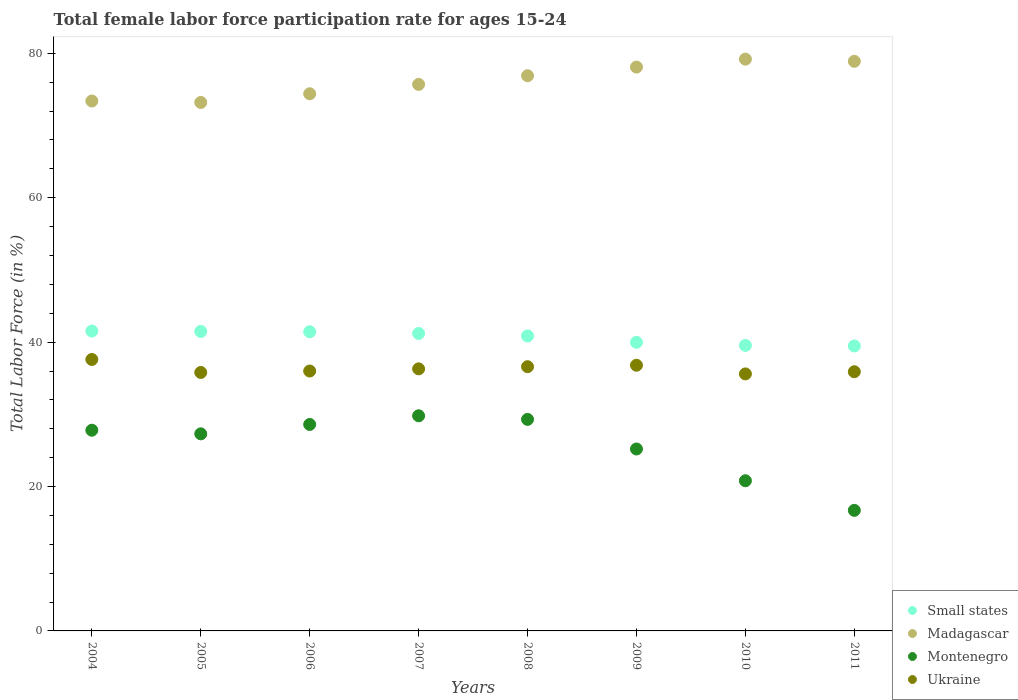How many different coloured dotlines are there?
Your answer should be compact. 4. What is the female labor force participation rate in Madagascar in 2009?
Ensure brevity in your answer.  78.1. Across all years, what is the maximum female labor force participation rate in Madagascar?
Your answer should be very brief. 79.2. Across all years, what is the minimum female labor force participation rate in Madagascar?
Your response must be concise. 73.2. What is the total female labor force participation rate in Small states in the graph?
Ensure brevity in your answer.  325.51. What is the difference between the female labor force participation rate in Madagascar in 2004 and that in 2008?
Ensure brevity in your answer.  -3.5. What is the difference between the female labor force participation rate in Small states in 2005 and the female labor force participation rate in Madagascar in 2007?
Offer a terse response. -34.21. What is the average female labor force participation rate in Ukraine per year?
Offer a terse response. 36.32. In the year 2006, what is the difference between the female labor force participation rate in Montenegro and female labor force participation rate in Ukraine?
Ensure brevity in your answer.  -7.4. In how many years, is the female labor force participation rate in Ukraine greater than 28 %?
Offer a terse response. 8. What is the ratio of the female labor force participation rate in Montenegro in 2008 to that in 2010?
Make the answer very short. 1.41. What is the difference between the highest and the second highest female labor force participation rate in Montenegro?
Your answer should be very brief. 0.5. What is the difference between the highest and the lowest female labor force participation rate in Madagascar?
Offer a very short reply. 6. Is the sum of the female labor force participation rate in Small states in 2004 and 2010 greater than the maximum female labor force participation rate in Madagascar across all years?
Make the answer very short. Yes. Is it the case that in every year, the sum of the female labor force participation rate in Ukraine and female labor force participation rate in Madagascar  is greater than the sum of female labor force participation rate in Small states and female labor force participation rate in Montenegro?
Your answer should be compact. Yes. Is it the case that in every year, the sum of the female labor force participation rate in Small states and female labor force participation rate in Ukraine  is greater than the female labor force participation rate in Montenegro?
Offer a very short reply. Yes. Does the female labor force participation rate in Madagascar monotonically increase over the years?
Your answer should be compact. No. Is the female labor force participation rate in Small states strictly greater than the female labor force participation rate in Madagascar over the years?
Keep it short and to the point. No. How many dotlines are there?
Ensure brevity in your answer.  4. How many years are there in the graph?
Your answer should be compact. 8. Where does the legend appear in the graph?
Ensure brevity in your answer.  Bottom right. What is the title of the graph?
Your response must be concise. Total female labor force participation rate for ages 15-24. What is the Total Labor Force (in %) of Small states in 2004?
Ensure brevity in your answer.  41.54. What is the Total Labor Force (in %) of Madagascar in 2004?
Offer a very short reply. 73.4. What is the Total Labor Force (in %) in Montenegro in 2004?
Make the answer very short. 27.8. What is the Total Labor Force (in %) of Ukraine in 2004?
Your response must be concise. 37.6. What is the Total Labor Force (in %) in Small states in 2005?
Make the answer very short. 41.49. What is the Total Labor Force (in %) in Madagascar in 2005?
Give a very brief answer. 73.2. What is the Total Labor Force (in %) in Montenegro in 2005?
Your response must be concise. 27.3. What is the Total Labor Force (in %) of Ukraine in 2005?
Make the answer very short. 35.8. What is the Total Labor Force (in %) in Small states in 2006?
Your answer should be very brief. 41.44. What is the Total Labor Force (in %) of Madagascar in 2006?
Give a very brief answer. 74.4. What is the Total Labor Force (in %) in Montenegro in 2006?
Keep it short and to the point. 28.6. What is the Total Labor Force (in %) in Ukraine in 2006?
Ensure brevity in your answer.  36. What is the Total Labor Force (in %) in Small states in 2007?
Your answer should be compact. 41.2. What is the Total Labor Force (in %) of Madagascar in 2007?
Give a very brief answer. 75.7. What is the Total Labor Force (in %) of Montenegro in 2007?
Ensure brevity in your answer.  29.8. What is the Total Labor Force (in %) in Ukraine in 2007?
Make the answer very short. 36.3. What is the Total Labor Force (in %) in Small states in 2008?
Provide a short and direct response. 40.86. What is the Total Labor Force (in %) in Madagascar in 2008?
Your answer should be very brief. 76.9. What is the Total Labor Force (in %) of Montenegro in 2008?
Provide a short and direct response. 29.3. What is the Total Labor Force (in %) of Ukraine in 2008?
Offer a very short reply. 36.6. What is the Total Labor Force (in %) of Small states in 2009?
Provide a succinct answer. 39.97. What is the Total Labor Force (in %) of Madagascar in 2009?
Your answer should be compact. 78.1. What is the Total Labor Force (in %) of Montenegro in 2009?
Your answer should be compact. 25.2. What is the Total Labor Force (in %) of Ukraine in 2009?
Provide a short and direct response. 36.8. What is the Total Labor Force (in %) of Small states in 2010?
Offer a very short reply. 39.54. What is the Total Labor Force (in %) in Madagascar in 2010?
Give a very brief answer. 79.2. What is the Total Labor Force (in %) in Montenegro in 2010?
Make the answer very short. 20.8. What is the Total Labor Force (in %) in Ukraine in 2010?
Offer a very short reply. 35.6. What is the Total Labor Force (in %) of Small states in 2011?
Your answer should be very brief. 39.47. What is the Total Labor Force (in %) in Madagascar in 2011?
Provide a short and direct response. 78.9. What is the Total Labor Force (in %) in Montenegro in 2011?
Keep it short and to the point. 16.7. What is the Total Labor Force (in %) of Ukraine in 2011?
Keep it short and to the point. 35.9. Across all years, what is the maximum Total Labor Force (in %) of Small states?
Your response must be concise. 41.54. Across all years, what is the maximum Total Labor Force (in %) in Madagascar?
Give a very brief answer. 79.2. Across all years, what is the maximum Total Labor Force (in %) in Montenegro?
Give a very brief answer. 29.8. Across all years, what is the maximum Total Labor Force (in %) of Ukraine?
Your response must be concise. 37.6. Across all years, what is the minimum Total Labor Force (in %) of Small states?
Give a very brief answer. 39.47. Across all years, what is the minimum Total Labor Force (in %) of Madagascar?
Keep it short and to the point. 73.2. Across all years, what is the minimum Total Labor Force (in %) of Montenegro?
Ensure brevity in your answer.  16.7. Across all years, what is the minimum Total Labor Force (in %) of Ukraine?
Ensure brevity in your answer.  35.6. What is the total Total Labor Force (in %) of Small states in the graph?
Make the answer very short. 325.51. What is the total Total Labor Force (in %) in Madagascar in the graph?
Offer a terse response. 609.8. What is the total Total Labor Force (in %) of Montenegro in the graph?
Keep it short and to the point. 205.5. What is the total Total Labor Force (in %) in Ukraine in the graph?
Offer a terse response. 290.6. What is the difference between the Total Labor Force (in %) of Small states in 2004 and that in 2005?
Your response must be concise. 0.05. What is the difference between the Total Labor Force (in %) of Ukraine in 2004 and that in 2005?
Provide a short and direct response. 1.8. What is the difference between the Total Labor Force (in %) in Small states in 2004 and that in 2006?
Your answer should be very brief. 0.1. What is the difference between the Total Labor Force (in %) in Madagascar in 2004 and that in 2006?
Provide a short and direct response. -1. What is the difference between the Total Labor Force (in %) in Ukraine in 2004 and that in 2006?
Ensure brevity in your answer.  1.6. What is the difference between the Total Labor Force (in %) in Small states in 2004 and that in 2007?
Provide a succinct answer. 0.34. What is the difference between the Total Labor Force (in %) of Montenegro in 2004 and that in 2007?
Offer a very short reply. -2. What is the difference between the Total Labor Force (in %) in Ukraine in 2004 and that in 2007?
Your answer should be very brief. 1.3. What is the difference between the Total Labor Force (in %) of Small states in 2004 and that in 2008?
Provide a succinct answer. 0.68. What is the difference between the Total Labor Force (in %) in Madagascar in 2004 and that in 2008?
Keep it short and to the point. -3.5. What is the difference between the Total Labor Force (in %) of Ukraine in 2004 and that in 2008?
Your answer should be very brief. 1. What is the difference between the Total Labor Force (in %) in Small states in 2004 and that in 2009?
Keep it short and to the point. 1.56. What is the difference between the Total Labor Force (in %) of Montenegro in 2004 and that in 2009?
Keep it short and to the point. 2.6. What is the difference between the Total Labor Force (in %) in Small states in 2004 and that in 2010?
Offer a very short reply. 1.99. What is the difference between the Total Labor Force (in %) of Madagascar in 2004 and that in 2010?
Your response must be concise. -5.8. What is the difference between the Total Labor Force (in %) of Montenegro in 2004 and that in 2010?
Provide a succinct answer. 7. What is the difference between the Total Labor Force (in %) of Ukraine in 2004 and that in 2010?
Make the answer very short. 2. What is the difference between the Total Labor Force (in %) in Small states in 2004 and that in 2011?
Provide a short and direct response. 2.06. What is the difference between the Total Labor Force (in %) in Madagascar in 2004 and that in 2011?
Provide a succinct answer. -5.5. What is the difference between the Total Labor Force (in %) in Ukraine in 2004 and that in 2011?
Make the answer very short. 1.7. What is the difference between the Total Labor Force (in %) in Small states in 2005 and that in 2006?
Your answer should be very brief. 0.05. What is the difference between the Total Labor Force (in %) in Madagascar in 2005 and that in 2006?
Your answer should be compact. -1.2. What is the difference between the Total Labor Force (in %) of Ukraine in 2005 and that in 2006?
Offer a very short reply. -0.2. What is the difference between the Total Labor Force (in %) of Small states in 2005 and that in 2007?
Your response must be concise. 0.29. What is the difference between the Total Labor Force (in %) of Ukraine in 2005 and that in 2007?
Provide a succinct answer. -0.5. What is the difference between the Total Labor Force (in %) of Small states in 2005 and that in 2008?
Your answer should be compact. 0.63. What is the difference between the Total Labor Force (in %) in Madagascar in 2005 and that in 2008?
Your response must be concise. -3.7. What is the difference between the Total Labor Force (in %) of Montenegro in 2005 and that in 2008?
Your answer should be compact. -2. What is the difference between the Total Labor Force (in %) of Ukraine in 2005 and that in 2008?
Your answer should be very brief. -0.8. What is the difference between the Total Labor Force (in %) in Small states in 2005 and that in 2009?
Offer a terse response. 1.51. What is the difference between the Total Labor Force (in %) of Ukraine in 2005 and that in 2009?
Offer a terse response. -1. What is the difference between the Total Labor Force (in %) of Small states in 2005 and that in 2010?
Provide a short and direct response. 1.94. What is the difference between the Total Labor Force (in %) in Madagascar in 2005 and that in 2010?
Offer a terse response. -6. What is the difference between the Total Labor Force (in %) in Small states in 2005 and that in 2011?
Provide a succinct answer. 2.01. What is the difference between the Total Labor Force (in %) in Madagascar in 2005 and that in 2011?
Offer a very short reply. -5.7. What is the difference between the Total Labor Force (in %) of Montenegro in 2005 and that in 2011?
Your answer should be compact. 10.6. What is the difference between the Total Labor Force (in %) in Small states in 2006 and that in 2007?
Your answer should be compact. 0.24. What is the difference between the Total Labor Force (in %) in Ukraine in 2006 and that in 2007?
Make the answer very short. -0.3. What is the difference between the Total Labor Force (in %) in Small states in 2006 and that in 2008?
Make the answer very short. 0.58. What is the difference between the Total Labor Force (in %) of Madagascar in 2006 and that in 2008?
Provide a succinct answer. -2.5. What is the difference between the Total Labor Force (in %) in Montenegro in 2006 and that in 2008?
Provide a succinct answer. -0.7. What is the difference between the Total Labor Force (in %) in Small states in 2006 and that in 2009?
Offer a very short reply. 1.47. What is the difference between the Total Labor Force (in %) of Small states in 2006 and that in 2010?
Keep it short and to the point. 1.9. What is the difference between the Total Labor Force (in %) of Small states in 2006 and that in 2011?
Make the answer very short. 1.97. What is the difference between the Total Labor Force (in %) in Madagascar in 2006 and that in 2011?
Provide a succinct answer. -4.5. What is the difference between the Total Labor Force (in %) in Ukraine in 2006 and that in 2011?
Provide a succinct answer. 0.1. What is the difference between the Total Labor Force (in %) of Small states in 2007 and that in 2008?
Keep it short and to the point. 0.34. What is the difference between the Total Labor Force (in %) of Madagascar in 2007 and that in 2008?
Your answer should be very brief. -1.2. What is the difference between the Total Labor Force (in %) in Small states in 2007 and that in 2009?
Offer a very short reply. 1.23. What is the difference between the Total Labor Force (in %) of Madagascar in 2007 and that in 2009?
Keep it short and to the point. -2.4. What is the difference between the Total Labor Force (in %) of Small states in 2007 and that in 2010?
Keep it short and to the point. 1.66. What is the difference between the Total Labor Force (in %) in Madagascar in 2007 and that in 2010?
Your answer should be very brief. -3.5. What is the difference between the Total Labor Force (in %) of Montenegro in 2007 and that in 2010?
Offer a very short reply. 9. What is the difference between the Total Labor Force (in %) in Small states in 2007 and that in 2011?
Give a very brief answer. 1.73. What is the difference between the Total Labor Force (in %) of Ukraine in 2007 and that in 2011?
Provide a short and direct response. 0.4. What is the difference between the Total Labor Force (in %) of Small states in 2008 and that in 2009?
Offer a very short reply. 0.88. What is the difference between the Total Labor Force (in %) in Madagascar in 2008 and that in 2009?
Offer a terse response. -1.2. What is the difference between the Total Labor Force (in %) in Small states in 2008 and that in 2010?
Your answer should be very brief. 1.31. What is the difference between the Total Labor Force (in %) of Madagascar in 2008 and that in 2010?
Offer a terse response. -2.3. What is the difference between the Total Labor Force (in %) of Small states in 2008 and that in 2011?
Provide a succinct answer. 1.39. What is the difference between the Total Labor Force (in %) of Montenegro in 2008 and that in 2011?
Ensure brevity in your answer.  12.6. What is the difference between the Total Labor Force (in %) of Small states in 2009 and that in 2010?
Offer a very short reply. 0.43. What is the difference between the Total Labor Force (in %) in Montenegro in 2009 and that in 2010?
Keep it short and to the point. 4.4. What is the difference between the Total Labor Force (in %) of Small states in 2009 and that in 2011?
Your answer should be very brief. 0.5. What is the difference between the Total Labor Force (in %) of Montenegro in 2009 and that in 2011?
Keep it short and to the point. 8.5. What is the difference between the Total Labor Force (in %) in Ukraine in 2009 and that in 2011?
Offer a terse response. 0.9. What is the difference between the Total Labor Force (in %) in Small states in 2010 and that in 2011?
Offer a very short reply. 0.07. What is the difference between the Total Labor Force (in %) of Small states in 2004 and the Total Labor Force (in %) of Madagascar in 2005?
Your answer should be compact. -31.66. What is the difference between the Total Labor Force (in %) of Small states in 2004 and the Total Labor Force (in %) of Montenegro in 2005?
Your answer should be compact. 14.24. What is the difference between the Total Labor Force (in %) of Small states in 2004 and the Total Labor Force (in %) of Ukraine in 2005?
Offer a very short reply. 5.74. What is the difference between the Total Labor Force (in %) of Madagascar in 2004 and the Total Labor Force (in %) of Montenegro in 2005?
Your answer should be compact. 46.1. What is the difference between the Total Labor Force (in %) in Madagascar in 2004 and the Total Labor Force (in %) in Ukraine in 2005?
Your answer should be compact. 37.6. What is the difference between the Total Labor Force (in %) in Montenegro in 2004 and the Total Labor Force (in %) in Ukraine in 2005?
Provide a succinct answer. -8. What is the difference between the Total Labor Force (in %) in Small states in 2004 and the Total Labor Force (in %) in Madagascar in 2006?
Ensure brevity in your answer.  -32.86. What is the difference between the Total Labor Force (in %) in Small states in 2004 and the Total Labor Force (in %) in Montenegro in 2006?
Your response must be concise. 12.94. What is the difference between the Total Labor Force (in %) of Small states in 2004 and the Total Labor Force (in %) of Ukraine in 2006?
Offer a very short reply. 5.54. What is the difference between the Total Labor Force (in %) of Madagascar in 2004 and the Total Labor Force (in %) of Montenegro in 2006?
Your answer should be very brief. 44.8. What is the difference between the Total Labor Force (in %) of Madagascar in 2004 and the Total Labor Force (in %) of Ukraine in 2006?
Ensure brevity in your answer.  37.4. What is the difference between the Total Labor Force (in %) in Montenegro in 2004 and the Total Labor Force (in %) in Ukraine in 2006?
Make the answer very short. -8.2. What is the difference between the Total Labor Force (in %) in Small states in 2004 and the Total Labor Force (in %) in Madagascar in 2007?
Keep it short and to the point. -34.16. What is the difference between the Total Labor Force (in %) of Small states in 2004 and the Total Labor Force (in %) of Montenegro in 2007?
Ensure brevity in your answer.  11.74. What is the difference between the Total Labor Force (in %) in Small states in 2004 and the Total Labor Force (in %) in Ukraine in 2007?
Your response must be concise. 5.24. What is the difference between the Total Labor Force (in %) of Madagascar in 2004 and the Total Labor Force (in %) of Montenegro in 2007?
Your response must be concise. 43.6. What is the difference between the Total Labor Force (in %) of Madagascar in 2004 and the Total Labor Force (in %) of Ukraine in 2007?
Offer a very short reply. 37.1. What is the difference between the Total Labor Force (in %) in Small states in 2004 and the Total Labor Force (in %) in Madagascar in 2008?
Keep it short and to the point. -35.36. What is the difference between the Total Labor Force (in %) of Small states in 2004 and the Total Labor Force (in %) of Montenegro in 2008?
Ensure brevity in your answer.  12.24. What is the difference between the Total Labor Force (in %) of Small states in 2004 and the Total Labor Force (in %) of Ukraine in 2008?
Offer a terse response. 4.94. What is the difference between the Total Labor Force (in %) of Madagascar in 2004 and the Total Labor Force (in %) of Montenegro in 2008?
Keep it short and to the point. 44.1. What is the difference between the Total Labor Force (in %) of Madagascar in 2004 and the Total Labor Force (in %) of Ukraine in 2008?
Ensure brevity in your answer.  36.8. What is the difference between the Total Labor Force (in %) in Montenegro in 2004 and the Total Labor Force (in %) in Ukraine in 2008?
Provide a succinct answer. -8.8. What is the difference between the Total Labor Force (in %) in Small states in 2004 and the Total Labor Force (in %) in Madagascar in 2009?
Ensure brevity in your answer.  -36.56. What is the difference between the Total Labor Force (in %) of Small states in 2004 and the Total Labor Force (in %) of Montenegro in 2009?
Make the answer very short. 16.34. What is the difference between the Total Labor Force (in %) in Small states in 2004 and the Total Labor Force (in %) in Ukraine in 2009?
Make the answer very short. 4.74. What is the difference between the Total Labor Force (in %) of Madagascar in 2004 and the Total Labor Force (in %) of Montenegro in 2009?
Offer a very short reply. 48.2. What is the difference between the Total Labor Force (in %) of Madagascar in 2004 and the Total Labor Force (in %) of Ukraine in 2009?
Ensure brevity in your answer.  36.6. What is the difference between the Total Labor Force (in %) of Montenegro in 2004 and the Total Labor Force (in %) of Ukraine in 2009?
Make the answer very short. -9. What is the difference between the Total Labor Force (in %) of Small states in 2004 and the Total Labor Force (in %) of Madagascar in 2010?
Give a very brief answer. -37.66. What is the difference between the Total Labor Force (in %) of Small states in 2004 and the Total Labor Force (in %) of Montenegro in 2010?
Provide a short and direct response. 20.74. What is the difference between the Total Labor Force (in %) in Small states in 2004 and the Total Labor Force (in %) in Ukraine in 2010?
Offer a terse response. 5.94. What is the difference between the Total Labor Force (in %) of Madagascar in 2004 and the Total Labor Force (in %) of Montenegro in 2010?
Give a very brief answer. 52.6. What is the difference between the Total Labor Force (in %) of Madagascar in 2004 and the Total Labor Force (in %) of Ukraine in 2010?
Your answer should be very brief. 37.8. What is the difference between the Total Labor Force (in %) in Montenegro in 2004 and the Total Labor Force (in %) in Ukraine in 2010?
Offer a very short reply. -7.8. What is the difference between the Total Labor Force (in %) of Small states in 2004 and the Total Labor Force (in %) of Madagascar in 2011?
Offer a very short reply. -37.36. What is the difference between the Total Labor Force (in %) of Small states in 2004 and the Total Labor Force (in %) of Montenegro in 2011?
Your answer should be very brief. 24.84. What is the difference between the Total Labor Force (in %) in Small states in 2004 and the Total Labor Force (in %) in Ukraine in 2011?
Ensure brevity in your answer.  5.64. What is the difference between the Total Labor Force (in %) in Madagascar in 2004 and the Total Labor Force (in %) in Montenegro in 2011?
Your answer should be compact. 56.7. What is the difference between the Total Labor Force (in %) of Madagascar in 2004 and the Total Labor Force (in %) of Ukraine in 2011?
Keep it short and to the point. 37.5. What is the difference between the Total Labor Force (in %) of Montenegro in 2004 and the Total Labor Force (in %) of Ukraine in 2011?
Ensure brevity in your answer.  -8.1. What is the difference between the Total Labor Force (in %) in Small states in 2005 and the Total Labor Force (in %) in Madagascar in 2006?
Offer a terse response. -32.91. What is the difference between the Total Labor Force (in %) of Small states in 2005 and the Total Labor Force (in %) of Montenegro in 2006?
Make the answer very short. 12.89. What is the difference between the Total Labor Force (in %) of Small states in 2005 and the Total Labor Force (in %) of Ukraine in 2006?
Your answer should be compact. 5.49. What is the difference between the Total Labor Force (in %) in Madagascar in 2005 and the Total Labor Force (in %) in Montenegro in 2006?
Your answer should be compact. 44.6. What is the difference between the Total Labor Force (in %) in Madagascar in 2005 and the Total Labor Force (in %) in Ukraine in 2006?
Your response must be concise. 37.2. What is the difference between the Total Labor Force (in %) in Montenegro in 2005 and the Total Labor Force (in %) in Ukraine in 2006?
Your answer should be very brief. -8.7. What is the difference between the Total Labor Force (in %) of Small states in 2005 and the Total Labor Force (in %) of Madagascar in 2007?
Offer a terse response. -34.21. What is the difference between the Total Labor Force (in %) of Small states in 2005 and the Total Labor Force (in %) of Montenegro in 2007?
Your answer should be compact. 11.69. What is the difference between the Total Labor Force (in %) of Small states in 2005 and the Total Labor Force (in %) of Ukraine in 2007?
Provide a succinct answer. 5.19. What is the difference between the Total Labor Force (in %) of Madagascar in 2005 and the Total Labor Force (in %) of Montenegro in 2007?
Your response must be concise. 43.4. What is the difference between the Total Labor Force (in %) in Madagascar in 2005 and the Total Labor Force (in %) in Ukraine in 2007?
Offer a very short reply. 36.9. What is the difference between the Total Labor Force (in %) of Small states in 2005 and the Total Labor Force (in %) of Madagascar in 2008?
Provide a short and direct response. -35.41. What is the difference between the Total Labor Force (in %) of Small states in 2005 and the Total Labor Force (in %) of Montenegro in 2008?
Offer a terse response. 12.19. What is the difference between the Total Labor Force (in %) of Small states in 2005 and the Total Labor Force (in %) of Ukraine in 2008?
Provide a short and direct response. 4.89. What is the difference between the Total Labor Force (in %) in Madagascar in 2005 and the Total Labor Force (in %) in Montenegro in 2008?
Offer a very short reply. 43.9. What is the difference between the Total Labor Force (in %) of Madagascar in 2005 and the Total Labor Force (in %) of Ukraine in 2008?
Offer a terse response. 36.6. What is the difference between the Total Labor Force (in %) of Small states in 2005 and the Total Labor Force (in %) of Madagascar in 2009?
Your answer should be very brief. -36.61. What is the difference between the Total Labor Force (in %) in Small states in 2005 and the Total Labor Force (in %) in Montenegro in 2009?
Make the answer very short. 16.29. What is the difference between the Total Labor Force (in %) of Small states in 2005 and the Total Labor Force (in %) of Ukraine in 2009?
Your answer should be very brief. 4.69. What is the difference between the Total Labor Force (in %) of Madagascar in 2005 and the Total Labor Force (in %) of Montenegro in 2009?
Offer a very short reply. 48. What is the difference between the Total Labor Force (in %) in Madagascar in 2005 and the Total Labor Force (in %) in Ukraine in 2009?
Offer a terse response. 36.4. What is the difference between the Total Labor Force (in %) of Small states in 2005 and the Total Labor Force (in %) of Madagascar in 2010?
Provide a short and direct response. -37.71. What is the difference between the Total Labor Force (in %) in Small states in 2005 and the Total Labor Force (in %) in Montenegro in 2010?
Keep it short and to the point. 20.69. What is the difference between the Total Labor Force (in %) of Small states in 2005 and the Total Labor Force (in %) of Ukraine in 2010?
Make the answer very short. 5.89. What is the difference between the Total Labor Force (in %) of Madagascar in 2005 and the Total Labor Force (in %) of Montenegro in 2010?
Your answer should be very brief. 52.4. What is the difference between the Total Labor Force (in %) of Madagascar in 2005 and the Total Labor Force (in %) of Ukraine in 2010?
Your answer should be compact. 37.6. What is the difference between the Total Labor Force (in %) in Montenegro in 2005 and the Total Labor Force (in %) in Ukraine in 2010?
Offer a very short reply. -8.3. What is the difference between the Total Labor Force (in %) of Small states in 2005 and the Total Labor Force (in %) of Madagascar in 2011?
Make the answer very short. -37.41. What is the difference between the Total Labor Force (in %) of Small states in 2005 and the Total Labor Force (in %) of Montenegro in 2011?
Your response must be concise. 24.79. What is the difference between the Total Labor Force (in %) in Small states in 2005 and the Total Labor Force (in %) in Ukraine in 2011?
Offer a terse response. 5.59. What is the difference between the Total Labor Force (in %) of Madagascar in 2005 and the Total Labor Force (in %) of Montenegro in 2011?
Keep it short and to the point. 56.5. What is the difference between the Total Labor Force (in %) of Madagascar in 2005 and the Total Labor Force (in %) of Ukraine in 2011?
Offer a terse response. 37.3. What is the difference between the Total Labor Force (in %) in Small states in 2006 and the Total Labor Force (in %) in Madagascar in 2007?
Your response must be concise. -34.26. What is the difference between the Total Labor Force (in %) in Small states in 2006 and the Total Labor Force (in %) in Montenegro in 2007?
Your response must be concise. 11.64. What is the difference between the Total Labor Force (in %) in Small states in 2006 and the Total Labor Force (in %) in Ukraine in 2007?
Your answer should be compact. 5.14. What is the difference between the Total Labor Force (in %) of Madagascar in 2006 and the Total Labor Force (in %) of Montenegro in 2007?
Your answer should be very brief. 44.6. What is the difference between the Total Labor Force (in %) in Madagascar in 2006 and the Total Labor Force (in %) in Ukraine in 2007?
Your response must be concise. 38.1. What is the difference between the Total Labor Force (in %) of Small states in 2006 and the Total Labor Force (in %) of Madagascar in 2008?
Provide a succinct answer. -35.46. What is the difference between the Total Labor Force (in %) of Small states in 2006 and the Total Labor Force (in %) of Montenegro in 2008?
Provide a succinct answer. 12.14. What is the difference between the Total Labor Force (in %) in Small states in 2006 and the Total Labor Force (in %) in Ukraine in 2008?
Offer a very short reply. 4.84. What is the difference between the Total Labor Force (in %) of Madagascar in 2006 and the Total Labor Force (in %) of Montenegro in 2008?
Ensure brevity in your answer.  45.1. What is the difference between the Total Labor Force (in %) of Madagascar in 2006 and the Total Labor Force (in %) of Ukraine in 2008?
Give a very brief answer. 37.8. What is the difference between the Total Labor Force (in %) of Montenegro in 2006 and the Total Labor Force (in %) of Ukraine in 2008?
Make the answer very short. -8. What is the difference between the Total Labor Force (in %) of Small states in 2006 and the Total Labor Force (in %) of Madagascar in 2009?
Give a very brief answer. -36.66. What is the difference between the Total Labor Force (in %) in Small states in 2006 and the Total Labor Force (in %) in Montenegro in 2009?
Provide a short and direct response. 16.24. What is the difference between the Total Labor Force (in %) of Small states in 2006 and the Total Labor Force (in %) of Ukraine in 2009?
Your response must be concise. 4.64. What is the difference between the Total Labor Force (in %) in Madagascar in 2006 and the Total Labor Force (in %) in Montenegro in 2009?
Make the answer very short. 49.2. What is the difference between the Total Labor Force (in %) in Madagascar in 2006 and the Total Labor Force (in %) in Ukraine in 2009?
Your response must be concise. 37.6. What is the difference between the Total Labor Force (in %) in Small states in 2006 and the Total Labor Force (in %) in Madagascar in 2010?
Keep it short and to the point. -37.76. What is the difference between the Total Labor Force (in %) in Small states in 2006 and the Total Labor Force (in %) in Montenegro in 2010?
Offer a terse response. 20.64. What is the difference between the Total Labor Force (in %) in Small states in 2006 and the Total Labor Force (in %) in Ukraine in 2010?
Your response must be concise. 5.84. What is the difference between the Total Labor Force (in %) of Madagascar in 2006 and the Total Labor Force (in %) of Montenegro in 2010?
Your response must be concise. 53.6. What is the difference between the Total Labor Force (in %) of Madagascar in 2006 and the Total Labor Force (in %) of Ukraine in 2010?
Your answer should be very brief. 38.8. What is the difference between the Total Labor Force (in %) in Small states in 2006 and the Total Labor Force (in %) in Madagascar in 2011?
Keep it short and to the point. -37.46. What is the difference between the Total Labor Force (in %) in Small states in 2006 and the Total Labor Force (in %) in Montenegro in 2011?
Your answer should be very brief. 24.74. What is the difference between the Total Labor Force (in %) of Small states in 2006 and the Total Labor Force (in %) of Ukraine in 2011?
Offer a very short reply. 5.54. What is the difference between the Total Labor Force (in %) in Madagascar in 2006 and the Total Labor Force (in %) in Montenegro in 2011?
Ensure brevity in your answer.  57.7. What is the difference between the Total Labor Force (in %) of Madagascar in 2006 and the Total Labor Force (in %) of Ukraine in 2011?
Offer a terse response. 38.5. What is the difference between the Total Labor Force (in %) in Montenegro in 2006 and the Total Labor Force (in %) in Ukraine in 2011?
Offer a terse response. -7.3. What is the difference between the Total Labor Force (in %) of Small states in 2007 and the Total Labor Force (in %) of Madagascar in 2008?
Make the answer very short. -35.7. What is the difference between the Total Labor Force (in %) of Small states in 2007 and the Total Labor Force (in %) of Montenegro in 2008?
Provide a succinct answer. 11.9. What is the difference between the Total Labor Force (in %) of Small states in 2007 and the Total Labor Force (in %) of Ukraine in 2008?
Ensure brevity in your answer.  4.6. What is the difference between the Total Labor Force (in %) of Madagascar in 2007 and the Total Labor Force (in %) of Montenegro in 2008?
Provide a short and direct response. 46.4. What is the difference between the Total Labor Force (in %) of Madagascar in 2007 and the Total Labor Force (in %) of Ukraine in 2008?
Make the answer very short. 39.1. What is the difference between the Total Labor Force (in %) in Montenegro in 2007 and the Total Labor Force (in %) in Ukraine in 2008?
Make the answer very short. -6.8. What is the difference between the Total Labor Force (in %) in Small states in 2007 and the Total Labor Force (in %) in Madagascar in 2009?
Your response must be concise. -36.9. What is the difference between the Total Labor Force (in %) in Small states in 2007 and the Total Labor Force (in %) in Montenegro in 2009?
Keep it short and to the point. 16. What is the difference between the Total Labor Force (in %) in Small states in 2007 and the Total Labor Force (in %) in Ukraine in 2009?
Ensure brevity in your answer.  4.4. What is the difference between the Total Labor Force (in %) of Madagascar in 2007 and the Total Labor Force (in %) of Montenegro in 2009?
Provide a short and direct response. 50.5. What is the difference between the Total Labor Force (in %) of Madagascar in 2007 and the Total Labor Force (in %) of Ukraine in 2009?
Offer a very short reply. 38.9. What is the difference between the Total Labor Force (in %) of Montenegro in 2007 and the Total Labor Force (in %) of Ukraine in 2009?
Keep it short and to the point. -7. What is the difference between the Total Labor Force (in %) of Small states in 2007 and the Total Labor Force (in %) of Madagascar in 2010?
Offer a terse response. -38. What is the difference between the Total Labor Force (in %) of Small states in 2007 and the Total Labor Force (in %) of Montenegro in 2010?
Provide a short and direct response. 20.4. What is the difference between the Total Labor Force (in %) of Small states in 2007 and the Total Labor Force (in %) of Ukraine in 2010?
Offer a very short reply. 5.6. What is the difference between the Total Labor Force (in %) of Madagascar in 2007 and the Total Labor Force (in %) of Montenegro in 2010?
Make the answer very short. 54.9. What is the difference between the Total Labor Force (in %) in Madagascar in 2007 and the Total Labor Force (in %) in Ukraine in 2010?
Your response must be concise. 40.1. What is the difference between the Total Labor Force (in %) in Small states in 2007 and the Total Labor Force (in %) in Madagascar in 2011?
Keep it short and to the point. -37.7. What is the difference between the Total Labor Force (in %) in Small states in 2007 and the Total Labor Force (in %) in Montenegro in 2011?
Ensure brevity in your answer.  24.5. What is the difference between the Total Labor Force (in %) in Small states in 2007 and the Total Labor Force (in %) in Ukraine in 2011?
Offer a terse response. 5.3. What is the difference between the Total Labor Force (in %) of Madagascar in 2007 and the Total Labor Force (in %) of Ukraine in 2011?
Offer a very short reply. 39.8. What is the difference between the Total Labor Force (in %) in Small states in 2008 and the Total Labor Force (in %) in Madagascar in 2009?
Offer a terse response. -37.24. What is the difference between the Total Labor Force (in %) in Small states in 2008 and the Total Labor Force (in %) in Montenegro in 2009?
Ensure brevity in your answer.  15.66. What is the difference between the Total Labor Force (in %) of Small states in 2008 and the Total Labor Force (in %) of Ukraine in 2009?
Make the answer very short. 4.06. What is the difference between the Total Labor Force (in %) in Madagascar in 2008 and the Total Labor Force (in %) in Montenegro in 2009?
Your response must be concise. 51.7. What is the difference between the Total Labor Force (in %) in Madagascar in 2008 and the Total Labor Force (in %) in Ukraine in 2009?
Provide a short and direct response. 40.1. What is the difference between the Total Labor Force (in %) of Small states in 2008 and the Total Labor Force (in %) of Madagascar in 2010?
Provide a succinct answer. -38.34. What is the difference between the Total Labor Force (in %) in Small states in 2008 and the Total Labor Force (in %) in Montenegro in 2010?
Offer a very short reply. 20.06. What is the difference between the Total Labor Force (in %) of Small states in 2008 and the Total Labor Force (in %) of Ukraine in 2010?
Provide a succinct answer. 5.26. What is the difference between the Total Labor Force (in %) of Madagascar in 2008 and the Total Labor Force (in %) of Montenegro in 2010?
Ensure brevity in your answer.  56.1. What is the difference between the Total Labor Force (in %) of Madagascar in 2008 and the Total Labor Force (in %) of Ukraine in 2010?
Ensure brevity in your answer.  41.3. What is the difference between the Total Labor Force (in %) of Small states in 2008 and the Total Labor Force (in %) of Madagascar in 2011?
Give a very brief answer. -38.04. What is the difference between the Total Labor Force (in %) of Small states in 2008 and the Total Labor Force (in %) of Montenegro in 2011?
Keep it short and to the point. 24.16. What is the difference between the Total Labor Force (in %) of Small states in 2008 and the Total Labor Force (in %) of Ukraine in 2011?
Provide a short and direct response. 4.96. What is the difference between the Total Labor Force (in %) in Madagascar in 2008 and the Total Labor Force (in %) in Montenegro in 2011?
Make the answer very short. 60.2. What is the difference between the Total Labor Force (in %) of Madagascar in 2008 and the Total Labor Force (in %) of Ukraine in 2011?
Offer a very short reply. 41. What is the difference between the Total Labor Force (in %) of Montenegro in 2008 and the Total Labor Force (in %) of Ukraine in 2011?
Make the answer very short. -6.6. What is the difference between the Total Labor Force (in %) of Small states in 2009 and the Total Labor Force (in %) of Madagascar in 2010?
Offer a terse response. -39.23. What is the difference between the Total Labor Force (in %) in Small states in 2009 and the Total Labor Force (in %) in Montenegro in 2010?
Offer a terse response. 19.17. What is the difference between the Total Labor Force (in %) of Small states in 2009 and the Total Labor Force (in %) of Ukraine in 2010?
Offer a very short reply. 4.37. What is the difference between the Total Labor Force (in %) in Madagascar in 2009 and the Total Labor Force (in %) in Montenegro in 2010?
Provide a succinct answer. 57.3. What is the difference between the Total Labor Force (in %) in Madagascar in 2009 and the Total Labor Force (in %) in Ukraine in 2010?
Your answer should be compact. 42.5. What is the difference between the Total Labor Force (in %) of Montenegro in 2009 and the Total Labor Force (in %) of Ukraine in 2010?
Provide a short and direct response. -10.4. What is the difference between the Total Labor Force (in %) of Small states in 2009 and the Total Labor Force (in %) of Madagascar in 2011?
Give a very brief answer. -38.93. What is the difference between the Total Labor Force (in %) in Small states in 2009 and the Total Labor Force (in %) in Montenegro in 2011?
Your answer should be compact. 23.27. What is the difference between the Total Labor Force (in %) of Small states in 2009 and the Total Labor Force (in %) of Ukraine in 2011?
Your answer should be compact. 4.07. What is the difference between the Total Labor Force (in %) of Madagascar in 2009 and the Total Labor Force (in %) of Montenegro in 2011?
Your answer should be very brief. 61.4. What is the difference between the Total Labor Force (in %) of Madagascar in 2009 and the Total Labor Force (in %) of Ukraine in 2011?
Give a very brief answer. 42.2. What is the difference between the Total Labor Force (in %) in Small states in 2010 and the Total Labor Force (in %) in Madagascar in 2011?
Offer a very short reply. -39.36. What is the difference between the Total Labor Force (in %) in Small states in 2010 and the Total Labor Force (in %) in Montenegro in 2011?
Provide a short and direct response. 22.84. What is the difference between the Total Labor Force (in %) in Small states in 2010 and the Total Labor Force (in %) in Ukraine in 2011?
Make the answer very short. 3.64. What is the difference between the Total Labor Force (in %) of Madagascar in 2010 and the Total Labor Force (in %) of Montenegro in 2011?
Make the answer very short. 62.5. What is the difference between the Total Labor Force (in %) in Madagascar in 2010 and the Total Labor Force (in %) in Ukraine in 2011?
Provide a succinct answer. 43.3. What is the difference between the Total Labor Force (in %) of Montenegro in 2010 and the Total Labor Force (in %) of Ukraine in 2011?
Your response must be concise. -15.1. What is the average Total Labor Force (in %) in Small states per year?
Your answer should be compact. 40.69. What is the average Total Labor Force (in %) of Madagascar per year?
Your response must be concise. 76.22. What is the average Total Labor Force (in %) in Montenegro per year?
Make the answer very short. 25.69. What is the average Total Labor Force (in %) of Ukraine per year?
Your response must be concise. 36.33. In the year 2004, what is the difference between the Total Labor Force (in %) of Small states and Total Labor Force (in %) of Madagascar?
Ensure brevity in your answer.  -31.86. In the year 2004, what is the difference between the Total Labor Force (in %) of Small states and Total Labor Force (in %) of Montenegro?
Your answer should be compact. 13.74. In the year 2004, what is the difference between the Total Labor Force (in %) of Small states and Total Labor Force (in %) of Ukraine?
Provide a succinct answer. 3.94. In the year 2004, what is the difference between the Total Labor Force (in %) of Madagascar and Total Labor Force (in %) of Montenegro?
Provide a short and direct response. 45.6. In the year 2004, what is the difference between the Total Labor Force (in %) in Madagascar and Total Labor Force (in %) in Ukraine?
Offer a terse response. 35.8. In the year 2004, what is the difference between the Total Labor Force (in %) of Montenegro and Total Labor Force (in %) of Ukraine?
Provide a succinct answer. -9.8. In the year 2005, what is the difference between the Total Labor Force (in %) in Small states and Total Labor Force (in %) in Madagascar?
Give a very brief answer. -31.71. In the year 2005, what is the difference between the Total Labor Force (in %) of Small states and Total Labor Force (in %) of Montenegro?
Keep it short and to the point. 14.19. In the year 2005, what is the difference between the Total Labor Force (in %) of Small states and Total Labor Force (in %) of Ukraine?
Make the answer very short. 5.69. In the year 2005, what is the difference between the Total Labor Force (in %) of Madagascar and Total Labor Force (in %) of Montenegro?
Offer a terse response. 45.9. In the year 2005, what is the difference between the Total Labor Force (in %) in Madagascar and Total Labor Force (in %) in Ukraine?
Provide a succinct answer. 37.4. In the year 2005, what is the difference between the Total Labor Force (in %) of Montenegro and Total Labor Force (in %) of Ukraine?
Ensure brevity in your answer.  -8.5. In the year 2006, what is the difference between the Total Labor Force (in %) of Small states and Total Labor Force (in %) of Madagascar?
Provide a short and direct response. -32.96. In the year 2006, what is the difference between the Total Labor Force (in %) of Small states and Total Labor Force (in %) of Montenegro?
Keep it short and to the point. 12.84. In the year 2006, what is the difference between the Total Labor Force (in %) of Small states and Total Labor Force (in %) of Ukraine?
Give a very brief answer. 5.44. In the year 2006, what is the difference between the Total Labor Force (in %) of Madagascar and Total Labor Force (in %) of Montenegro?
Provide a short and direct response. 45.8. In the year 2006, what is the difference between the Total Labor Force (in %) of Madagascar and Total Labor Force (in %) of Ukraine?
Offer a very short reply. 38.4. In the year 2006, what is the difference between the Total Labor Force (in %) of Montenegro and Total Labor Force (in %) of Ukraine?
Your answer should be very brief. -7.4. In the year 2007, what is the difference between the Total Labor Force (in %) of Small states and Total Labor Force (in %) of Madagascar?
Provide a short and direct response. -34.5. In the year 2007, what is the difference between the Total Labor Force (in %) of Small states and Total Labor Force (in %) of Montenegro?
Offer a terse response. 11.4. In the year 2007, what is the difference between the Total Labor Force (in %) in Small states and Total Labor Force (in %) in Ukraine?
Keep it short and to the point. 4.9. In the year 2007, what is the difference between the Total Labor Force (in %) of Madagascar and Total Labor Force (in %) of Montenegro?
Make the answer very short. 45.9. In the year 2007, what is the difference between the Total Labor Force (in %) of Madagascar and Total Labor Force (in %) of Ukraine?
Your answer should be very brief. 39.4. In the year 2008, what is the difference between the Total Labor Force (in %) of Small states and Total Labor Force (in %) of Madagascar?
Provide a short and direct response. -36.04. In the year 2008, what is the difference between the Total Labor Force (in %) in Small states and Total Labor Force (in %) in Montenegro?
Make the answer very short. 11.56. In the year 2008, what is the difference between the Total Labor Force (in %) of Small states and Total Labor Force (in %) of Ukraine?
Keep it short and to the point. 4.26. In the year 2008, what is the difference between the Total Labor Force (in %) in Madagascar and Total Labor Force (in %) in Montenegro?
Your answer should be very brief. 47.6. In the year 2008, what is the difference between the Total Labor Force (in %) in Madagascar and Total Labor Force (in %) in Ukraine?
Keep it short and to the point. 40.3. In the year 2009, what is the difference between the Total Labor Force (in %) of Small states and Total Labor Force (in %) of Madagascar?
Your answer should be compact. -38.13. In the year 2009, what is the difference between the Total Labor Force (in %) in Small states and Total Labor Force (in %) in Montenegro?
Your answer should be compact. 14.77. In the year 2009, what is the difference between the Total Labor Force (in %) in Small states and Total Labor Force (in %) in Ukraine?
Your response must be concise. 3.17. In the year 2009, what is the difference between the Total Labor Force (in %) of Madagascar and Total Labor Force (in %) of Montenegro?
Your response must be concise. 52.9. In the year 2009, what is the difference between the Total Labor Force (in %) in Madagascar and Total Labor Force (in %) in Ukraine?
Your response must be concise. 41.3. In the year 2010, what is the difference between the Total Labor Force (in %) of Small states and Total Labor Force (in %) of Madagascar?
Give a very brief answer. -39.66. In the year 2010, what is the difference between the Total Labor Force (in %) in Small states and Total Labor Force (in %) in Montenegro?
Provide a succinct answer. 18.74. In the year 2010, what is the difference between the Total Labor Force (in %) of Small states and Total Labor Force (in %) of Ukraine?
Your answer should be compact. 3.94. In the year 2010, what is the difference between the Total Labor Force (in %) of Madagascar and Total Labor Force (in %) of Montenegro?
Give a very brief answer. 58.4. In the year 2010, what is the difference between the Total Labor Force (in %) in Madagascar and Total Labor Force (in %) in Ukraine?
Ensure brevity in your answer.  43.6. In the year 2010, what is the difference between the Total Labor Force (in %) of Montenegro and Total Labor Force (in %) of Ukraine?
Provide a short and direct response. -14.8. In the year 2011, what is the difference between the Total Labor Force (in %) of Small states and Total Labor Force (in %) of Madagascar?
Your answer should be compact. -39.43. In the year 2011, what is the difference between the Total Labor Force (in %) in Small states and Total Labor Force (in %) in Montenegro?
Your answer should be compact. 22.77. In the year 2011, what is the difference between the Total Labor Force (in %) of Small states and Total Labor Force (in %) of Ukraine?
Your answer should be compact. 3.57. In the year 2011, what is the difference between the Total Labor Force (in %) in Madagascar and Total Labor Force (in %) in Montenegro?
Keep it short and to the point. 62.2. In the year 2011, what is the difference between the Total Labor Force (in %) in Madagascar and Total Labor Force (in %) in Ukraine?
Offer a terse response. 43. In the year 2011, what is the difference between the Total Labor Force (in %) of Montenegro and Total Labor Force (in %) of Ukraine?
Offer a very short reply. -19.2. What is the ratio of the Total Labor Force (in %) of Small states in 2004 to that in 2005?
Your answer should be compact. 1. What is the ratio of the Total Labor Force (in %) of Montenegro in 2004 to that in 2005?
Your answer should be compact. 1.02. What is the ratio of the Total Labor Force (in %) of Ukraine in 2004 to that in 2005?
Your answer should be compact. 1.05. What is the ratio of the Total Labor Force (in %) in Small states in 2004 to that in 2006?
Offer a very short reply. 1. What is the ratio of the Total Labor Force (in %) in Madagascar in 2004 to that in 2006?
Your answer should be very brief. 0.99. What is the ratio of the Total Labor Force (in %) in Montenegro in 2004 to that in 2006?
Offer a terse response. 0.97. What is the ratio of the Total Labor Force (in %) in Ukraine in 2004 to that in 2006?
Give a very brief answer. 1.04. What is the ratio of the Total Labor Force (in %) in Small states in 2004 to that in 2007?
Keep it short and to the point. 1.01. What is the ratio of the Total Labor Force (in %) in Madagascar in 2004 to that in 2007?
Your response must be concise. 0.97. What is the ratio of the Total Labor Force (in %) in Montenegro in 2004 to that in 2007?
Your answer should be compact. 0.93. What is the ratio of the Total Labor Force (in %) in Ukraine in 2004 to that in 2007?
Ensure brevity in your answer.  1.04. What is the ratio of the Total Labor Force (in %) of Small states in 2004 to that in 2008?
Give a very brief answer. 1.02. What is the ratio of the Total Labor Force (in %) of Madagascar in 2004 to that in 2008?
Your answer should be very brief. 0.95. What is the ratio of the Total Labor Force (in %) in Montenegro in 2004 to that in 2008?
Provide a short and direct response. 0.95. What is the ratio of the Total Labor Force (in %) in Ukraine in 2004 to that in 2008?
Offer a very short reply. 1.03. What is the ratio of the Total Labor Force (in %) of Small states in 2004 to that in 2009?
Offer a very short reply. 1.04. What is the ratio of the Total Labor Force (in %) in Madagascar in 2004 to that in 2009?
Make the answer very short. 0.94. What is the ratio of the Total Labor Force (in %) of Montenegro in 2004 to that in 2009?
Your answer should be compact. 1.1. What is the ratio of the Total Labor Force (in %) in Ukraine in 2004 to that in 2009?
Offer a very short reply. 1.02. What is the ratio of the Total Labor Force (in %) in Small states in 2004 to that in 2010?
Provide a succinct answer. 1.05. What is the ratio of the Total Labor Force (in %) of Madagascar in 2004 to that in 2010?
Your response must be concise. 0.93. What is the ratio of the Total Labor Force (in %) of Montenegro in 2004 to that in 2010?
Your answer should be very brief. 1.34. What is the ratio of the Total Labor Force (in %) in Ukraine in 2004 to that in 2010?
Your answer should be very brief. 1.06. What is the ratio of the Total Labor Force (in %) of Small states in 2004 to that in 2011?
Keep it short and to the point. 1.05. What is the ratio of the Total Labor Force (in %) in Madagascar in 2004 to that in 2011?
Your answer should be compact. 0.93. What is the ratio of the Total Labor Force (in %) of Montenegro in 2004 to that in 2011?
Your answer should be very brief. 1.66. What is the ratio of the Total Labor Force (in %) of Ukraine in 2004 to that in 2011?
Offer a very short reply. 1.05. What is the ratio of the Total Labor Force (in %) in Madagascar in 2005 to that in 2006?
Ensure brevity in your answer.  0.98. What is the ratio of the Total Labor Force (in %) of Montenegro in 2005 to that in 2006?
Ensure brevity in your answer.  0.95. What is the ratio of the Total Labor Force (in %) of Madagascar in 2005 to that in 2007?
Keep it short and to the point. 0.97. What is the ratio of the Total Labor Force (in %) of Montenegro in 2005 to that in 2007?
Give a very brief answer. 0.92. What is the ratio of the Total Labor Force (in %) in Ukraine in 2005 to that in 2007?
Your answer should be compact. 0.99. What is the ratio of the Total Labor Force (in %) of Small states in 2005 to that in 2008?
Ensure brevity in your answer.  1.02. What is the ratio of the Total Labor Force (in %) of Madagascar in 2005 to that in 2008?
Your answer should be very brief. 0.95. What is the ratio of the Total Labor Force (in %) of Montenegro in 2005 to that in 2008?
Your answer should be compact. 0.93. What is the ratio of the Total Labor Force (in %) in Ukraine in 2005 to that in 2008?
Your answer should be compact. 0.98. What is the ratio of the Total Labor Force (in %) of Small states in 2005 to that in 2009?
Your answer should be very brief. 1.04. What is the ratio of the Total Labor Force (in %) in Madagascar in 2005 to that in 2009?
Ensure brevity in your answer.  0.94. What is the ratio of the Total Labor Force (in %) of Ukraine in 2005 to that in 2009?
Provide a succinct answer. 0.97. What is the ratio of the Total Labor Force (in %) of Small states in 2005 to that in 2010?
Provide a succinct answer. 1.05. What is the ratio of the Total Labor Force (in %) in Madagascar in 2005 to that in 2010?
Provide a short and direct response. 0.92. What is the ratio of the Total Labor Force (in %) of Montenegro in 2005 to that in 2010?
Make the answer very short. 1.31. What is the ratio of the Total Labor Force (in %) of Ukraine in 2005 to that in 2010?
Keep it short and to the point. 1.01. What is the ratio of the Total Labor Force (in %) of Small states in 2005 to that in 2011?
Your answer should be very brief. 1.05. What is the ratio of the Total Labor Force (in %) in Madagascar in 2005 to that in 2011?
Offer a terse response. 0.93. What is the ratio of the Total Labor Force (in %) in Montenegro in 2005 to that in 2011?
Your answer should be very brief. 1.63. What is the ratio of the Total Labor Force (in %) in Ukraine in 2005 to that in 2011?
Your response must be concise. 1. What is the ratio of the Total Labor Force (in %) of Madagascar in 2006 to that in 2007?
Provide a succinct answer. 0.98. What is the ratio of the Total Labor Force (in %) in Montenegro in 2006 to that in 2007?
Provide a short and direct response. 0.96. What is the ratio of the Total Labor Force (in %) of Small states in 2006 to that in 2008?
Keep it short and to the point. 1.01. What is the ratio of the Total Labor Force (in %) of Madagascar in 2006 to that in 2008?
Ensure brevity in your answer.  0.97. What is the ratio of the Total Labor Force (in %) of Montenegro in 2006 to that in 2008?
Make the answer very short. 0.98. What is the ratio of the Total Labor Force (in %) in Ukraine in 2006 to that in 2008?
Keep it short and to the point. 0.98. What is the ratio of the Total Labor Force (in %) in Small states in 2006 to that in 2009?
Give a very brief answer. 1.04. What is the ratio of the Total Labor Force (in %) of Madagascar in 2006 to that in 2009?
Your answer should be very brief. 0.95. What is the ratio of the Total Labor Force (in %) of Montenegro in 2006 to that in 2009?
Offer a terse response. 1.13. What is the ratio of the Total Labor Force (in %) in Ukraine in 2006 to that in 2009?
Your answer should be very brief. 0.98. What is the ratio of the Total Labor Force (in %) of Small states in 2006 to that in 2010?
Your response must be concise. 1.05. What is the ratio of the Total Labor Force (in %) of Madagascar in 2006 to that in 2010?
Keep it short and to the point. 0.94. What is the ratio of the Total Labor Force (in %) of Montenegro in 2006 to that in 2010?
Make the answer very short. 1.38. What is the ratio of the Total Labor Force (in %) in Ukraine in 2006 to that in 2010?
Keep it short and to the point. 1.01. What is the ratio of the Total Labor Force (in %) of Small states in 2006 to that in 2011?
Your answer should be compact. 1.05. What is the ratio of the Total Labor Force (in %) in Madagascar in 2006 to that in 2011?
Your answer should be very brief. 0.94. What is the ratio of the Total Labor Force (in %) of Montenegro in 2006 to that in 2011?
Provide a short and direct response. 1.71. What is the ratio of the Total Labor Force (in %) in Small states in 2007 to that in 2008?
Make the answer very short. 1.01. What is the ratio of the Total Labor Force (in %) in Madagascar in 2007 to that in 2008?
Ensure brevity in your answer.  0.98. What is the ratio of the Total Labor Force (in %) of Montenegro in 2007 to that in 2008?
Provide a succinct answer. 1.02. What is the ratio of the Total Labor Force (in %) of Ukraine in 2007 to that in 2008?
Ensure brevity in your answer.  0.99. What is the ratio of the Total Labor Force (in %) of Small states in 2007 to that in 2009?
Your answer should be compact. 1.03. What is the ratio of the Total Labor Force (in %) in Madagascar in 2007 to that in 2009?
Your answer should be compact. 0.97. What is the ratio of the Total Labor Force (in %) of Montenegro in 2007 to that in 2009?
Keep it short and to the point. 1.18. What is the ratio of the Total Labor Force (in %) in Ukraine in 2007 to that in 2009?
Offer a very short reply. 0.99. What is the ratio of the Total Labor Force (in %) in Small states in 2007 to that in 2010?
Your answer should be compact. 1.04. What is the ratio of the Total Labor Force (in %) of Madagascar in 2007 to that in 2010?
Keep it short and to the point. 0.96. What is the ratio of the Total Labor Force (in %) in Montenegro in 2007 to that in 2010?
Your answer should be compact. 1.43. What is the ratio of the Total Labor Force (in %) of Ukraine in 2007 to that in 2010?
Provide a short and direct response. 1.02. What is the ratio of the Total Labor Force (in %) of Small states in 2007 to that in 2011?
Give a very brief answer. 1.04. What is the ratio of the Total Labor Force (in %) of Madagascar in 2007 to that in 2011?
Your answer should be compact. 0.96. What is the ratio of the Total Labor Force (in %) in Montenegro in 2007 to that in 2011?
Ensure brevity in your answer.  1.78. What is the ratio of the Total Labor Force (in %) of Ukraine in 2007 to that in 2011?
Offer a very short reply. 1.01. What is the ratio of the Total Labor Force (in %) in Small states in 2008 to that in 2009?
Your answer should be very brief. 1.02. What is the ratio of the Total Labor Force (in %) of Madagascar in 2008 to that in 2009?
Ensure brevity in your answer.  0.98. What is the ratio of the Total Labor Force (in %) in Montenegro in 2008 to that in 2009?
Your answer should be very brief. 1.16. What is the ratio of the Total Labor Force (in %) of Ukraine in 2008 to that in 2009?
Offer a terse response. 0.99. What is the ratio of the Total Labor Force (in %) in Small states in 2008 to that in 2010?
Keep it short and to the point. 1.03. What is the ratio of the Total Labor Force (in %) in Madagascar in 2008 to that in 2010?
Offer a very short reply. 0.97. What is the ratio of the Total Labor Force (in %) of Montenegro in 2008 to that in 2010?
Give a very brief answer. 1.41. What is the ratio of the Total Labor Force (in %) in Ukraine in 2008 to that in 2010?
Offer a very short reply. 1.03. What is the ratio of the Total Labor Force (in %) of Small states in 2008 to that in 2011?
Offer a terse response. 1.04. What is the ratio of the Total Labor Force (in %) of Madagascar in 2008 to that in 2011?
Offer a very short reply. 0.97. What is the ratio of the Total Labor Force (in %) of Montenegro in 2008 to that in 2011?
Provide a short and direct response. 1.75. What is the ratio of the Total Labor Force (in %) in Ukraine in 2008 to that in 2011?
Make the answer very short. 1.02. What is the ratio of the Total Labor Force (in %) in Small states in 2009 to that in 2010?
Give a very brief answer. 1.01. What is the ratio of the Total Labor Force (in %) of Madagascar in 2009 to that in 2010?
Provide a short and direct response. 0.99. What is the ratio of the Total Labor Force (in %) in Montenegro in 2009 to that in 2010?
Ensure brevity in your answer.  1.21. What is the ratio of the Total Labor Force (in %) in Ukraine in 2009 to that in 2010?
Make the answer very short. 1.03. What is the ratio of the Total Labor Force (in %) in Small states in 2009 to that in 2011?
Offer a very short reply. 1.01. What is the ratio of the Total Labor Force (in %) in Madagascar in 2009 to that in 2011?
Your response must be concise. 0.99. What is the ratio of the Total Labor Force (in %) in Montenegro in 2009 to that in 2011?
Provide a succinct answer. 1.51. What is the ratio of the Total Labor Force (in %) of Ukraine in 2009 to that in 2011?
Provide a short and direct response. 1.03. What is the ratio of the Total Labor Force (in %) in Montenegro in 2010 to that in 2011?
Offer a very short reply. 1.25. What is the difference between the highest and the second highest Total Labor Force (in %) of Small states?
Provide a succinct answer. 0.05. What is the difference between the highest and the second highest Total Labor Force (in %) of Ukraine?
Your response must be concise. 0.8. What is the difference between the highest and the lowest Total Labor Force (in %) of Small states?
Your answer should be compact. 2.06. What is the difference between the highest and the lowest Total Labor Force (in %) in Ukraine?
Your answer should be very brief. 2. 